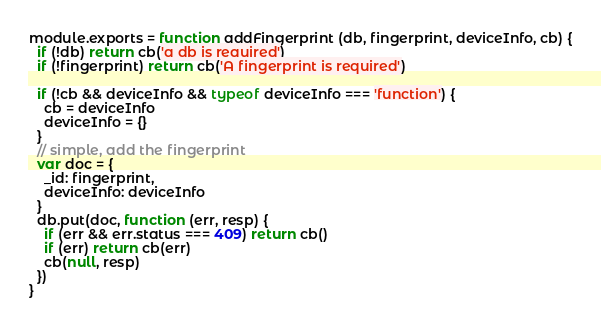<code> <loc_0><loc_0><loc_500><loc_500><_JavaScript_>module.exports = function addFingerprint (db, fingerprint, deviceInfo, cb) {
  if (!db) return cb('a db is required')
  if (!fingerprint) return cb('A fingerprint is required')

  if (!cb && deviceInfo && typeof deviceInfo === 'function') {
    cb = deviceInfo
    deviceInfo = {}
  }
  // simple, add the fingerprint
  var doc = {
    _id: fingerprint,
    deviceInfo: deviceInfo
  }
  db.put(doc, function (err, resp) {
    if (err && err.status === 409) return cb()
    if (err) return cb(err)
    cb(null, resp)
  })
}
</code> 